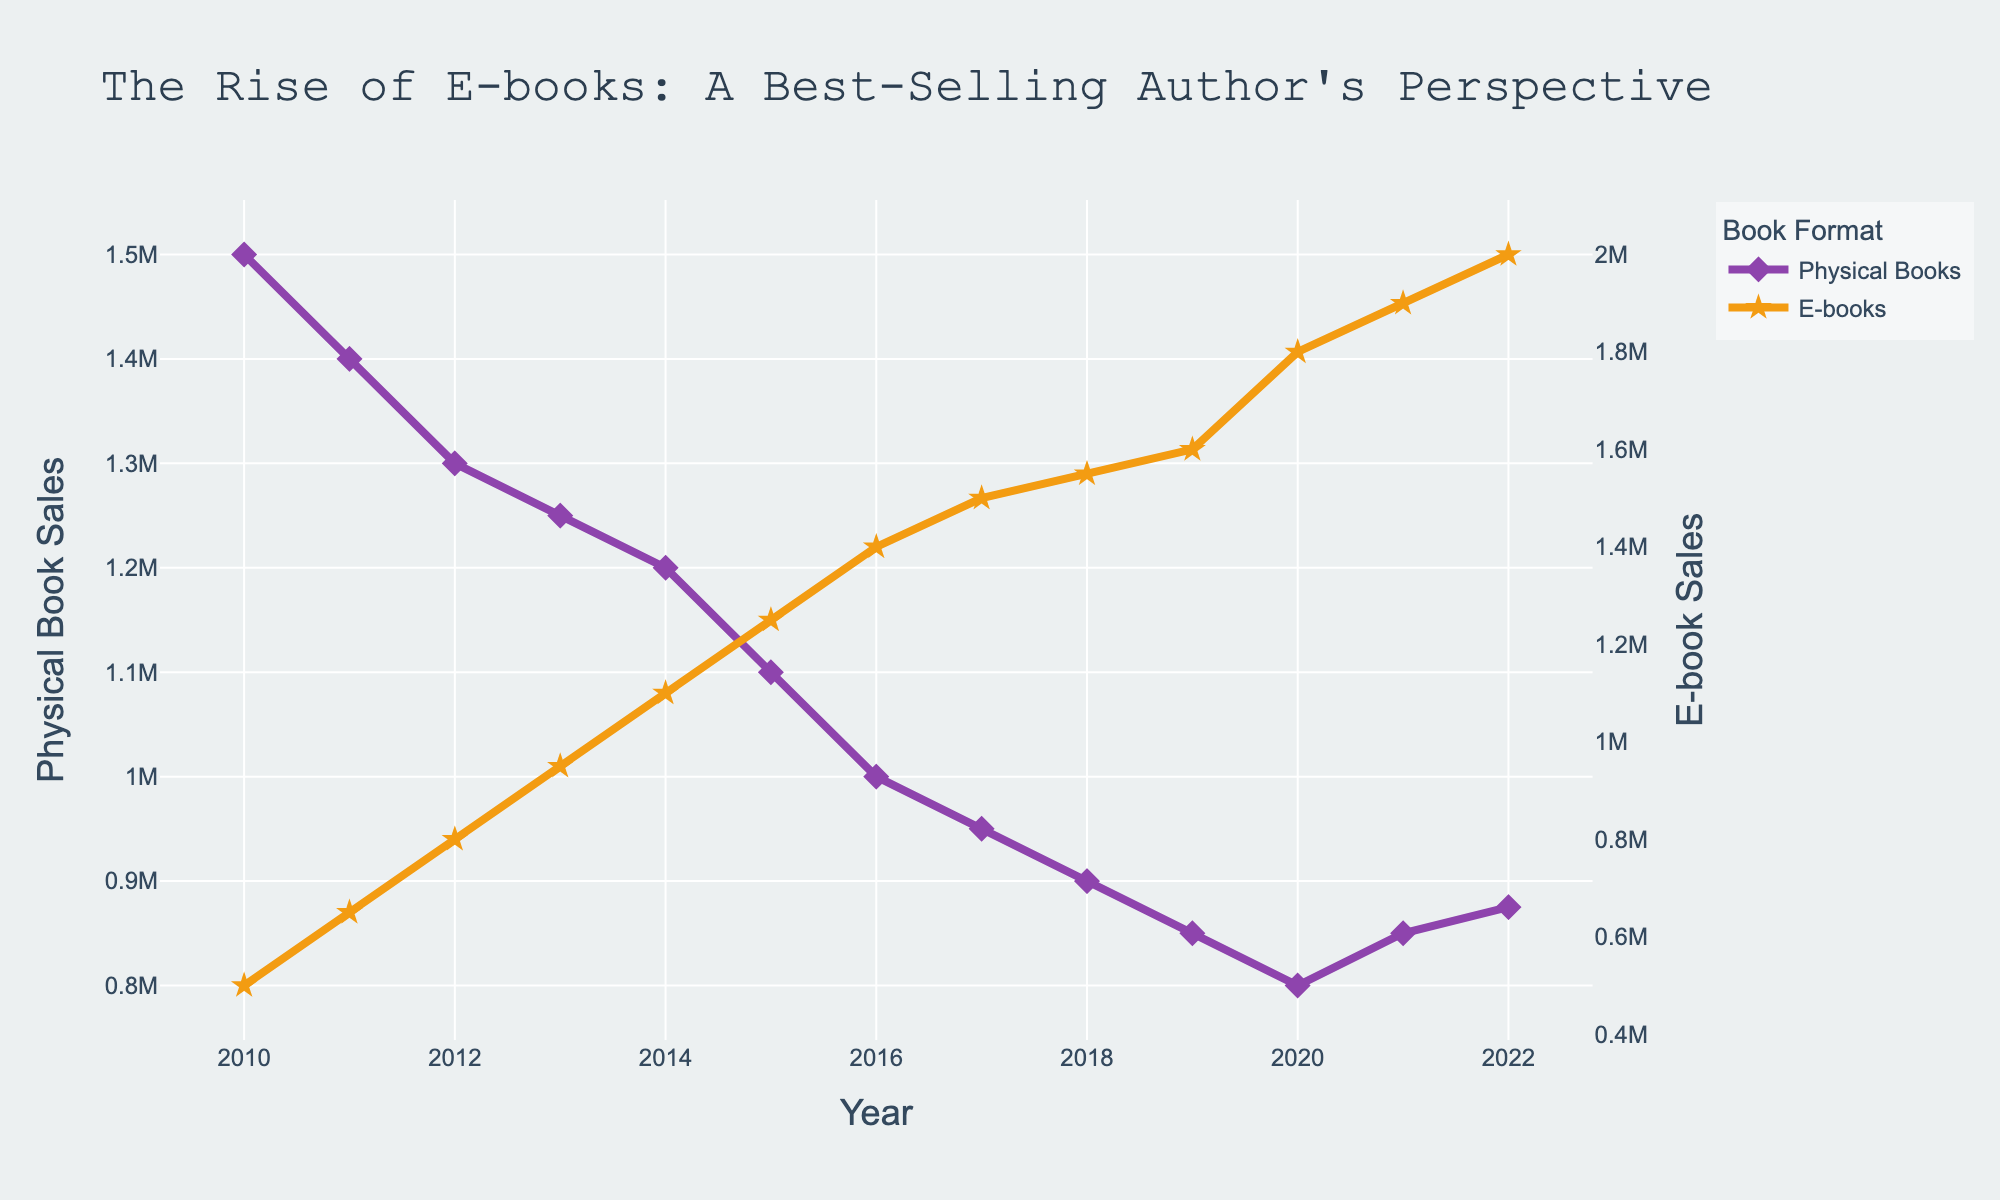What is the title of the figure? The title of a figure is usually located at the top. In this case, it reads "The Rise of E-books: A Best-Selling Author's Perspective".
Answer: The Rise of E-books: A Best-Selling Author's Perspective What does the x-axis represent? The x-axis shows the time period over which the data is collected, which is labeled as "Year".
Answer: Year What is the trend in physical book sales between 2010 and 2022? Looking at the plot, physical book sales show a declining trend from 2010 to 2022.
Answer: Declining Which year saw the highest E-book sales according to the plot? Observing the y-values for E-book sales, the highest point occurs in the year 2022.
Answer: 2022 What was the approximate difference in physical book sales between 2010 and 2020? To find the difference, subtract the sales in 2020 from those in 2010: 1,500,000 - 800,000 = 700,000.
Answer: 700,000 When did E-book sales surpass physical book sales? Checking the plot, E-book sales surpass physical book sales in the year 2015.
Answer: 2015 By how much did E-book sales increase from 2010 to 2022? Subtract the E-book sales in 2010 from those in 2022: 2,000,000 - 500,000 = 1,500,000.
Answer: 1,500,000 In which year were physical book sales and E-book sales closest to each other? The year 2014 shows the closest proximity of the two sales figures before E-book sales surpass physical book sales in 2015.
Answer: 2014 What are the primary colors used for the physical book and E-book lines? The colors of the lines are purple for physical books and orange for E-books.
Answer: purple for physical books, orange for E-books How did E-book sales compare to physical book sales in 2021? In 2021, E-book sales (1,900,000) were significantly higher than physical book sales (850,000).
Answer: E-book sales were higher 